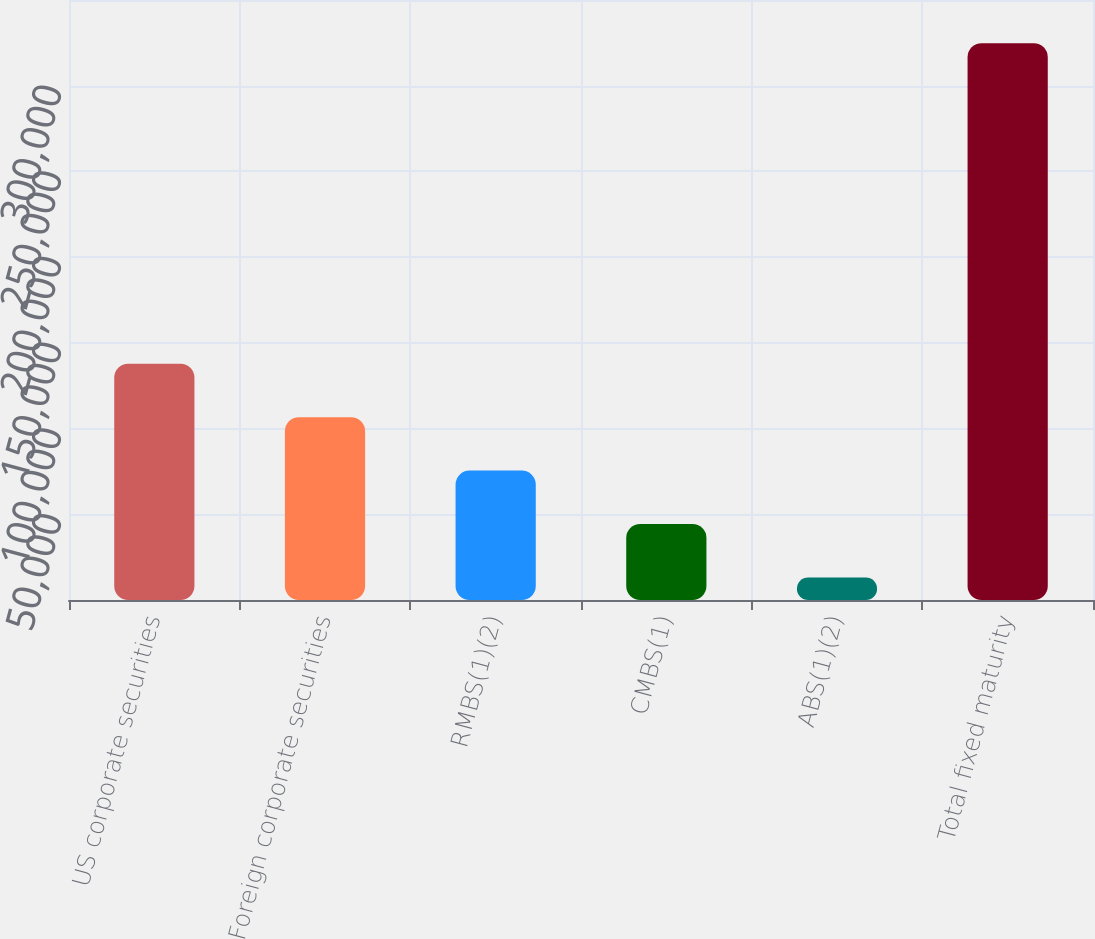<chart> <loc_0><loc_0><loc_500><loc_500><bar_chart><fcel>US corporate securities<fcel>Foreign corporate securities<fcel>RMBS(1)(2)<fcel>CMBS(1)<fcel>ABS(1)(2)<fcel>Total fixed maturity<nl><fcel>137820<fcel>106657<fcel>75493.8<fcel>44330.9<fcel>13168<fcel>324797<nl></chart> 